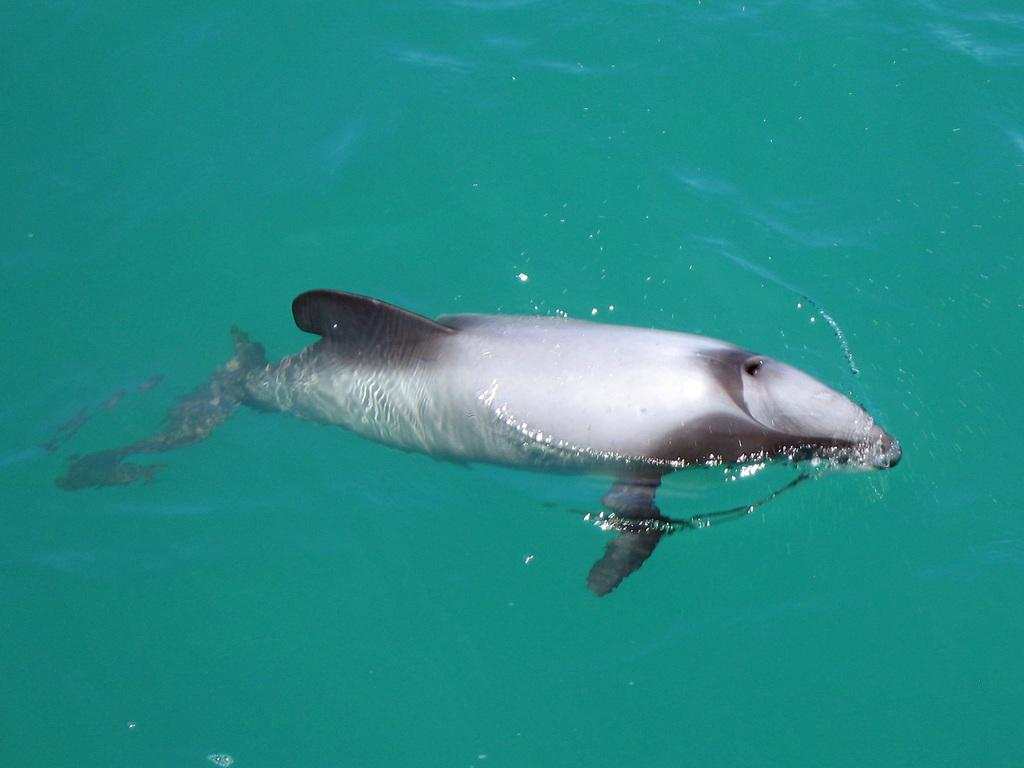What type of animal can be seen in the water in the image? There is a fish in the water in the image. What type of cap is the fish wearing in the image? There is no cap present in the image, as the subject is a fish in the water. 